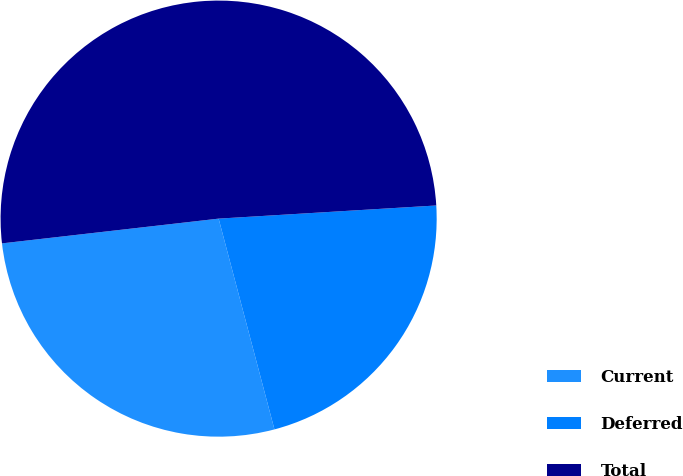Convert chart. <chart><loc_0><loc_0><loc_500><loc_500><pie_chart><fcel>Current<fcel>Deferred<fcel>Total<nl><fcel>27.31%<fcel>21.84%<fcel>50.85%<nl></chart> 